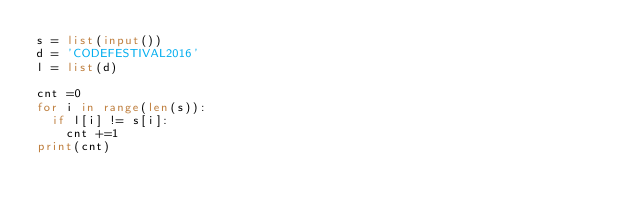Convert code to text. <code><loc_0><loc_0><loc_500><loc_500><_Python_>s = list(input())
d = 'CODEFESTIVAL2016'
l = list(d)

cnt =0
for i in range(len(s)):
  if l[i] != s[i]:
    cnt +=1
print(cnt)</code> 